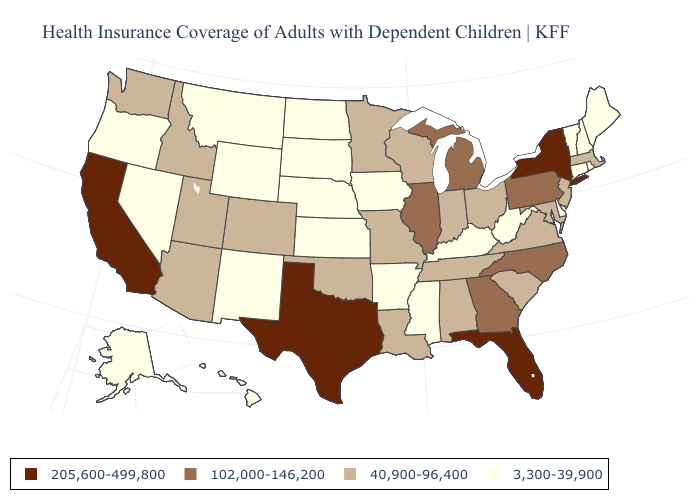What is the lowest value in states that border Maine?
Be succinct. 3,300-39,900. Name the states that have a value in the range 102,000-146,200?
Be succinct. Georgia, Illinois, Michigan, North Carolina, Pennsylvania. What is the highest value in the USA?
Give a very brief answer. 205,600-499,800. Which states have the lowest value in the USA?
Give a very brief answer. Alaska, Arkansas, Connecticut, Delaware, Hawaii, Iowa, Kansas, Kentucky, Maine, Mississippi, Montana, Nebraska, Nevada, New Hampshire, New Mexico, North Dakota, Oregon, Rhode Island, South Dakota, Vermont, West Virginia, Wyoming. What is the lowest value in the MidWest?
Concise answer only. 3,300-39,900. Name the states that have a value in the range 40,900-96,400?
Concise answer only. Alabama, Arizona, Colorado, Idaho, Indiana, Louisiana, Maryland, Massachusetts, Minnesota, Missouri, New Jersey, Ohio, Oklahoma, South Carolina, Tennessee, Utah, Virginia, Washington, Wisconsin. Name the states that have a value in the range 205,600-499,800?
Quick response, please. California, Florida, New York, Texas. Does Oregon have the same value as Mississippi?
Keep it brief. Yes. Does Arizona have the lowest value in the USA?
Be succinct. No. What is the value of Kentucky?
Quick response, please. 3,300-39,900. What is the value of Kansas?
Concise answer only. 3,300-39,900. Does Utah have the lowest value in the West?
Quick response, please. No. Name the states that have a value in the range 3,300-39,900?
Be succinct. Alaska, Arkansas, Connecticut, Delaware, Hawaii, Iowa, Kansas, Kentucky, Maine, Mississippi, Montana, Nebraska, Nevada, New Hampshire, New Mexico, North Dakota, Oregon, Rhode Island, South Dakota, Vermont, West Virginia, Wyoming. Does Oklahoma have a lower value than Wisconsin?
Concise answer only. No. What is the value of New Jersey?
Give a very brief answer. 40,900-96,400. 